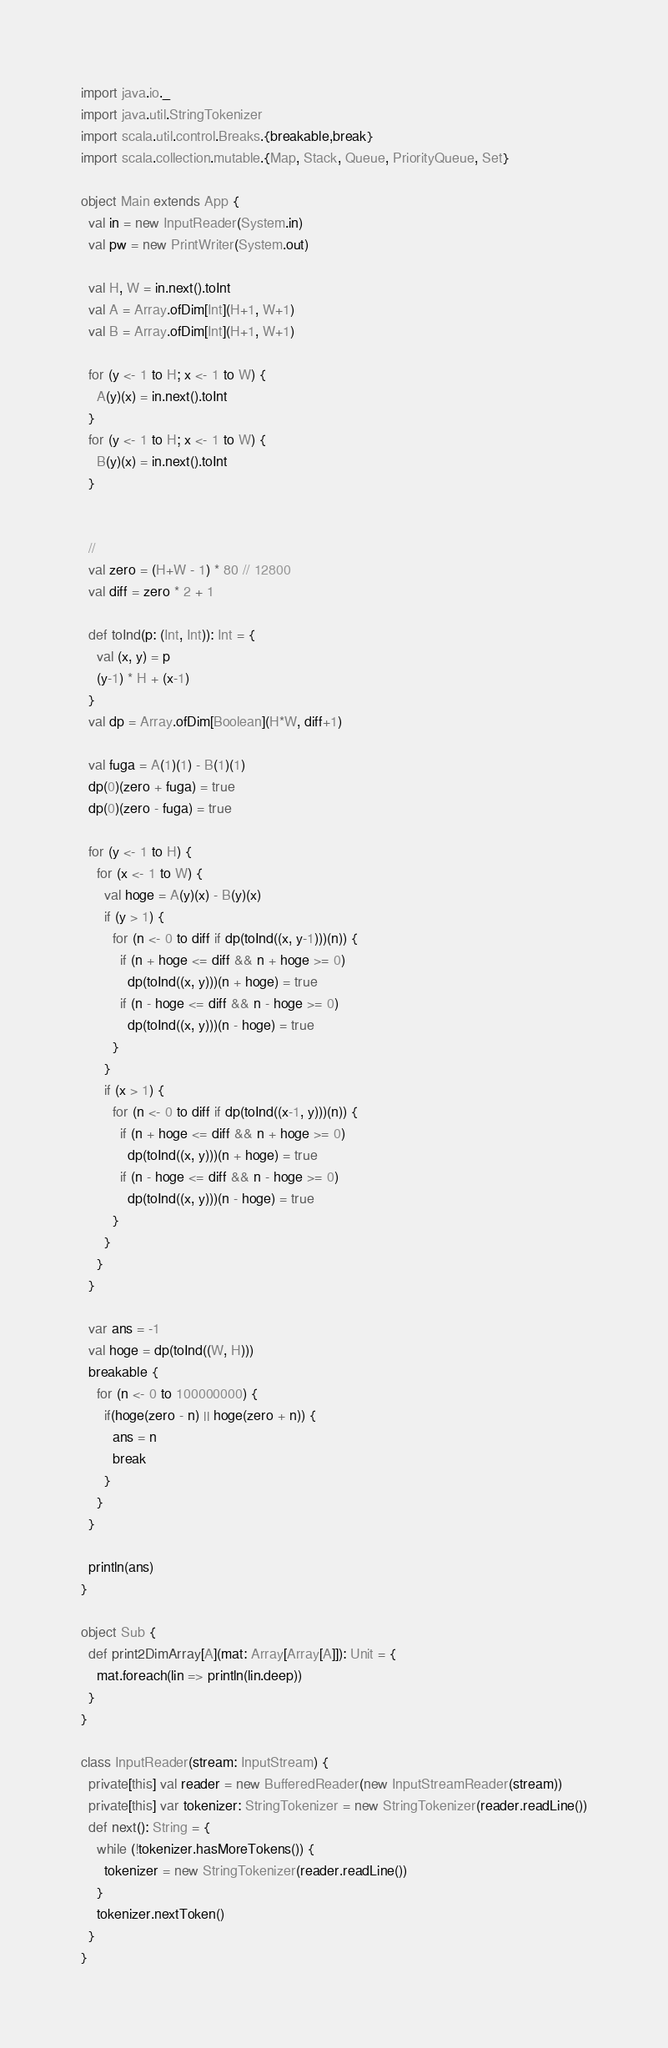<code> <loc_0><loc_0><loc_500><loc_500><_Scala_>import java.io._
import java.util.StringTokenizer
import scala.util.control.Breaks.{breakable,break}
import scala.collection.mutable.{Map, Stack, Queue, PriorityQueue, Set}

object Main extends App {
  val in = new InputReader(System.in)
  val pw = new PrintWriter(System.out)

  val H, W = in.next().toInt
  val A = Array.ofDim[Int](H+1, W+1)
  val B = Array.ofDim[Int](H+1, W+1)

  for (y <- 1 to H; x <- 1 to W) {
    A(y)(x) = in.next().toInt
  }
  for (y <- 1 to H; x <- 1 to W) {
    B(y)(x) = in.next().toInt
  }


  //
  val zero = (H+W - 1) * 80 // 12800
  val diff = zero * 2 + 1

  def toInd(p: (Int, Int)): Int = {
    val (x, y) = p
    (y-1) * H + (x-1)
  }
  val dp = Array.ofDim[Boolean](H*W, diff+1)

  val fuga = A(1)(1) - B(1)(1)
  dp(0)(zero + fuga) = true
  dp(0)(zero - fuga) = true

  for (y <- 1 to H) {
    for (x <- 1 to W) {
      val hoge = A(y)(x) - B(y)(x)
      if (y > 1) {
        for (n <- 0 to diff if dp(toInd((x, y-1)))(n)) {
          if (n + hoge <= diff && n + hoge >= 0)
            dp(toInd((x, y)))(n + hoge) = true
          if (n - hoge <= diff && n - hoge >= 0)
            dp(toInd((x, y)))(n - hoge) = true
        }
      }
      if (x > 1) {
        for (n <- 0 to diff if dp(toInd((x-1, y)))(n)) {
          if (n + hoge <= diff && n + hoge >= 0)
            dp(toInd((x, y)))(n + hoge) = true
          if (n - hoge <= diff && n - hoge >= 0)
            dp(toInd((x, y)))(n - hoge) = true
        }
      }
    }
  }

  var ans = -1
  val hoge = dp(toInd((W, H)))
  breakable {
    for (n <- 0 to 100000000) {
      if(hoge(zero - n) || hoge(zero + n)) {
        ans = n
        break
      }
    }
  }

  println(ans)
}

object Sub {
  def print2DimArray[A](mat: Array[Array[A]]): Unit = {
    mat.foreach(lin => println(lin.deep))
  }
}

class InputReader(stream: InputStream) {
  private[this] val reader = new BufferedReader(new InputStreamReader(stream))
  private[this] var tokenizer: StringTokenizer = new StringTokenizer(reader.readLine())
  def next(): String = {
    while (!tokenizer.hasMoreTokens()) {
      tokenizer = new StringTokenizer(reader.readLine())
    }
    tokenizer.nextToken()
  }
}
</code> 